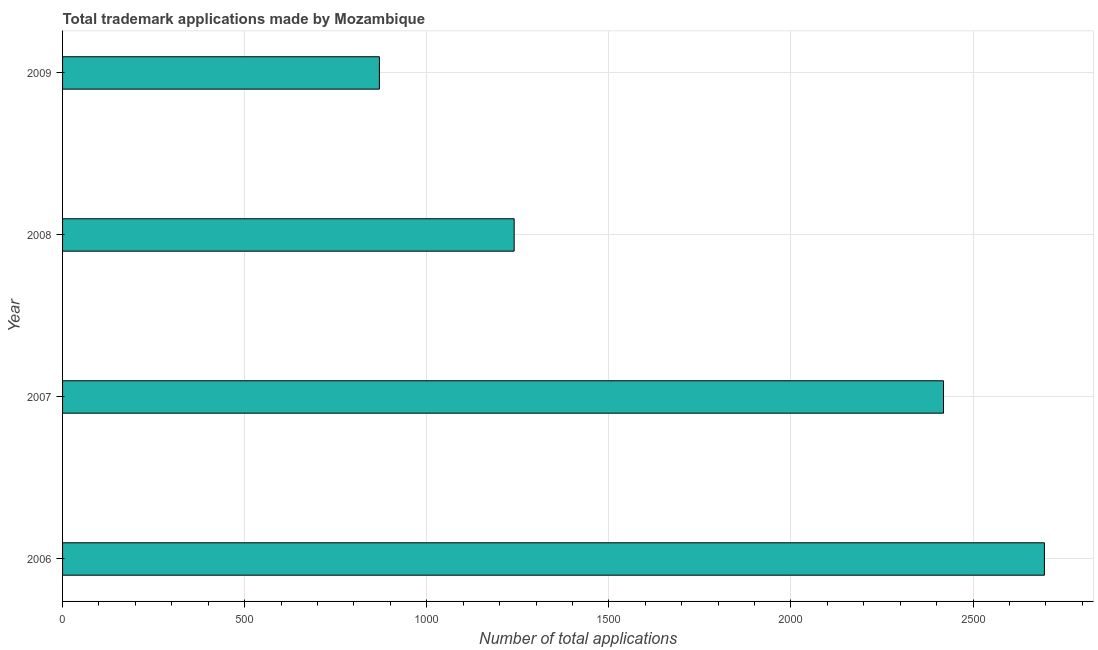Does the graph contain any zero values?
Your answer should be very brief. No. What is the title of the graph?
Offer a terse response. Total trademark applications made by Mozambique. What is the label or title of the X-axis?
Your answer should be compact. Number of total applications. What is the label or title of the Y-axis?
Provide a short and direct response. Year. What is the number of trademark applications in 2008?
Make the answer very short. 1240. Across all years, what is the maximum number of trademark applications?
Offer a very short reply. 2696. Across all years, what is the minimum number of trademark applications?
Keep it short and to the point. 870. In which year was the number of trademark applications maximum?
Your response must be concise. 2006. What is the sum of the number of trademark applications?
Keep it short and to the point. 7225. What is the difference between the number of trademark applications in 2006 and 2008?
Offer a terse response. 1456. What is the average number of trademark applications per year?
Provide a short and direct response. 1806. What is the median number of trademark applications?
Ensure brevity in your answer.  1829.5. Do a majority of the years between 2008 and 2009 (inclusive) have number of trademark applications greater than 1800 ?
Your response must be concise. No. What is the ratio of the number of trademark applications in 2006 to that in 2007?
Offer a terse response. 1.11. Is the number of trademark applications in 2006 less than that in 2007?
Your answer should be very brief. No. Is the difference between the number of trademark applications in 2006 and 2007 greater than the difference between any two years?
Give a very brief answer. No. What is the difference between the highest and the second highest number of trademark applications?
Your answer should be very brief. 277. What is the difference between the highest and the lowest number of trademark applications?
Offer a terse response. 1826. Are the values on the major ticks of X-axis written in scientific E-notation?
Keep it short and to the point. No. What is the Number of total applications in 2006?
Give a very brief answer. 2696. What is the Number of total applications of 2007?
Make the answer very short. 2419. What is the Number of total applications in 2008?
Provide a short and direct response. 1240. What is the Number of total applications of 2009?
Your answer should be very brief. 870. What is the difference between the Number of total applications in 2006 and 2007?
Provide a succinct answer. 277. What is the difference between the Number of total applications in 2006 and 2008?
Provide a short and direct response. 1456. What is the difference between the Number of total applications in 2006 and 2009?
Provide a short and direct response. 1826. What is the difference between the Number of total applications in 2007 and 2008?
Offer a very short reply. 1179. What is the difference between the Number of total applications in 2007 and 2009?
Offer a terse response. 1549. What is the difference between the Number of total applications in 2008 and 2009?
Your answer should be compact. 370. What is the ratio of the Number of total applications in 2006 to that in 2007?
Offer a terse response. 1.11. What is the ratio of the Number of total applications in 2006 to that in 2008?
Your answer should be very brief. 2.17. What is the ratio of the Number of total applications in 2006 to that in 2009?
Your answer should be very brief. 3.1. What is the ratio of the Number of total applications in 2007 to that in 2008?
Offer a very short reply. 1.95. What is the ratio of the Number of total applications in 2007 to that in 2009?
Ensure brevity in your answer.  2.78. What is the ratio of the Number of total applications in 2008 to that in 2009?
Your answer should be compact. 1.43. 